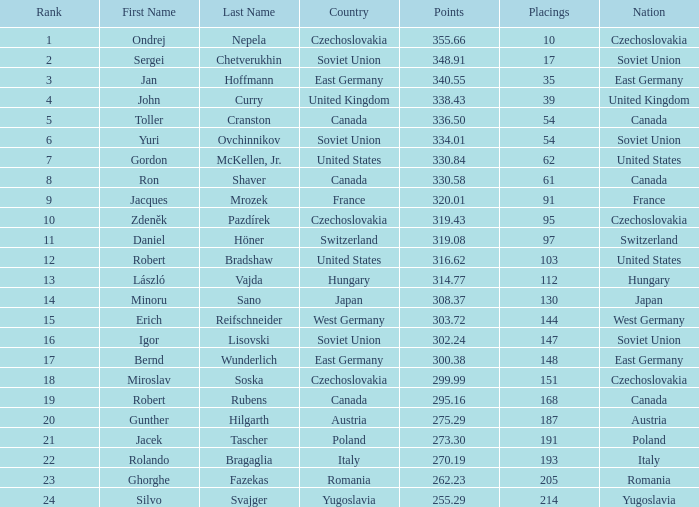What is the number of placings with points below 330.84 and a name of silvo svajger? 1.0. 